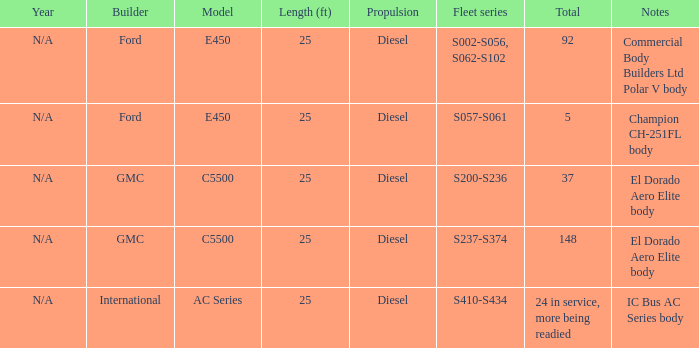Who is the builder with a fleet series of s057 to s061? Ford. 